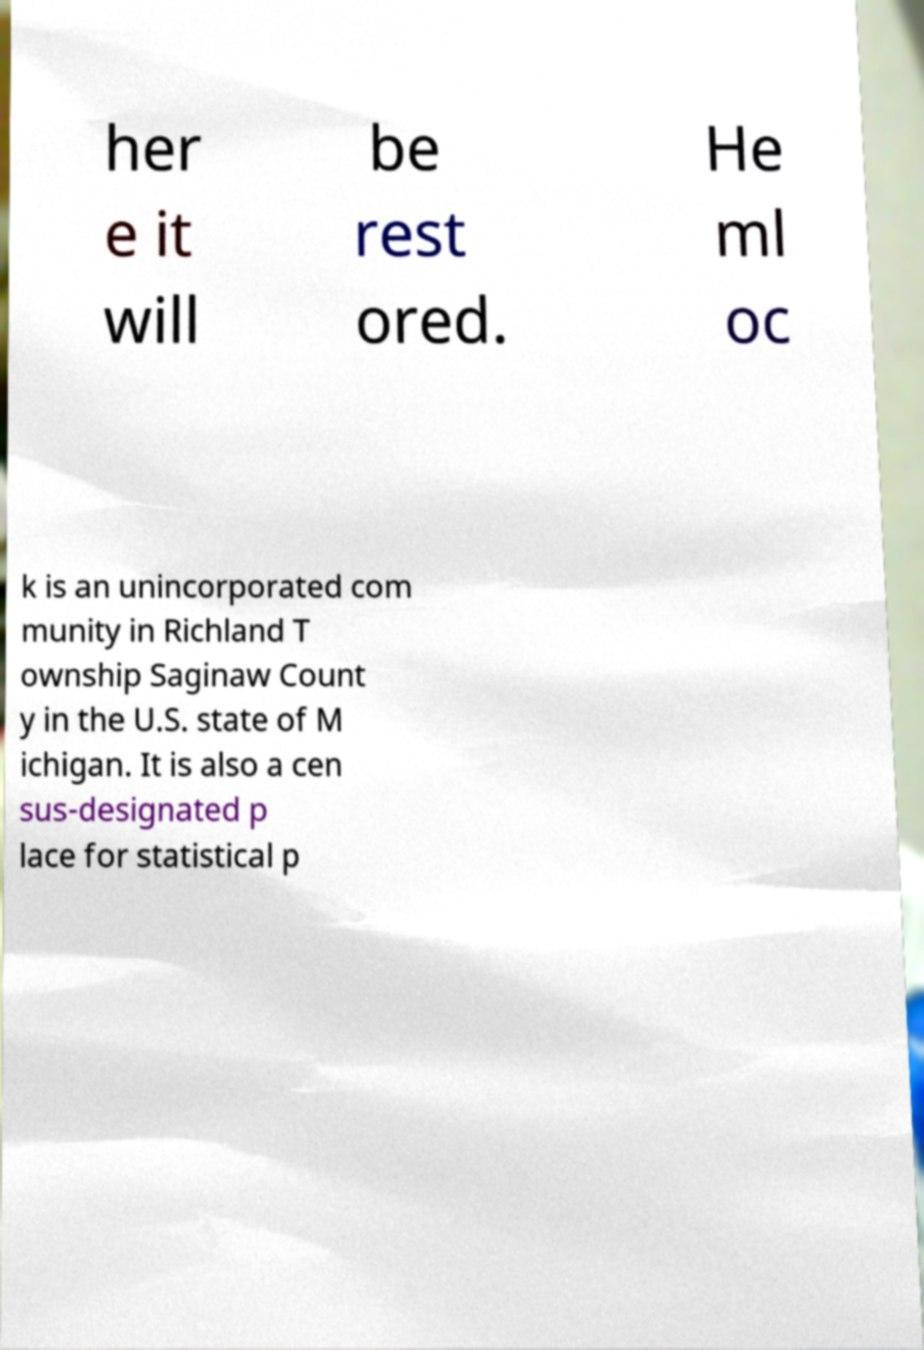Could you extract and type out the text from this image? her e it will be rest ored. He ml oc k is an unincorporated com munity in Richland T ownship Saginaw Count y in the U.S. state of M ichigan. It is also a cen sus-designated p lace for statistical p 